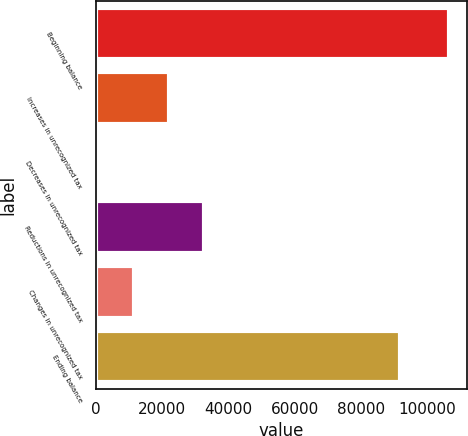Convert chart to OTSL. <chart><loc_0><loc_0><loc_500><loc_500><bar_chart><fcel>Beginning balance<fcel>Increases in unrecognized tax<fcel>Decreases in unrecognized tax<fcel>Reductions in unrecognized tax<fcel>Changes in unrecognized tax<fcel>Ending balance<nl><fcel>106542<fcel>21935.6<fcel>784<fcel>32511.4<fcel>11359.8<fcel>91637<nl></chart> 